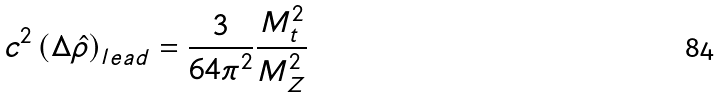Convert formula to latex. <formula><loc_0><loc_0><loc_500><loc_500>c ^ { 2 } \left ( \Delta \hat { \rho } \right ) _ { l e a d } = \frac { 3 } { 6 4 \pi ^ { 2 } } \frac { M _ { t } ^ { 2 } } { M _ { Z } ^ { 2 } }</formula> 